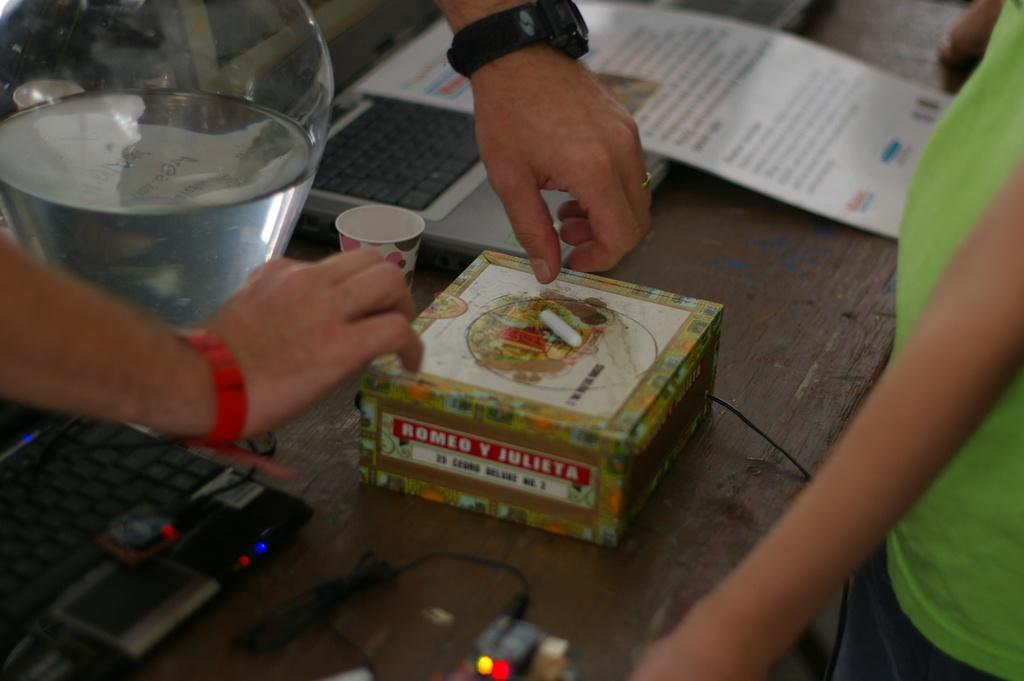What type of furniture is present in the image? There is a table in the image. What electronic devices are on the table? There are laptops on the table. What other object can be seen on the table? There is a glass object on the table. What type of container is in the image? There is a box in the image. Whose hands are visible in the image? A person's hands are visible in the image. What is the position of the person in the image? There is a person standing in the image. What type of friction is present between the person's hands and the laptop in the image? There is no information about the type of friction between the person's hands and the laptop in the image. Is there a throne in the image? No, there is no throne present in the image. 